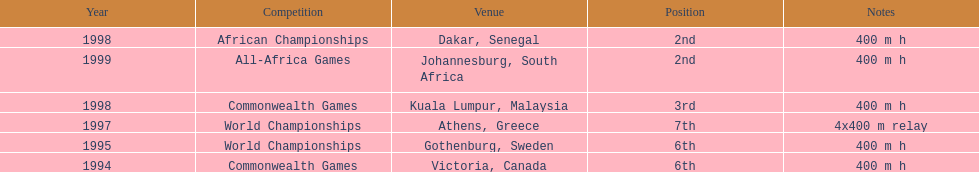What is the last competition on the chart? All-Africa Games. 